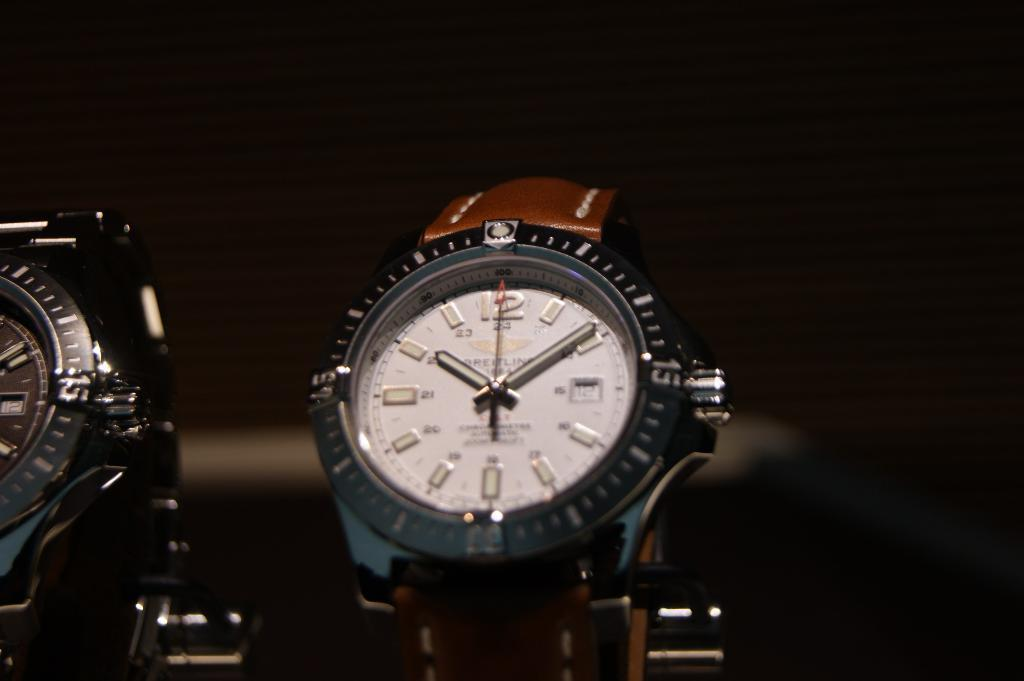<image>
Share a concise interpretation of the image provided. A watch with the time ten past two is on display. 